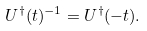Convert formula to latex. <formula><loc_0><loc_0><loc_500><loc_500>U ^ { \dagger } ( t ) ^ { - 1 } = U ^ { \dagger } ( - t ) .</formula> 